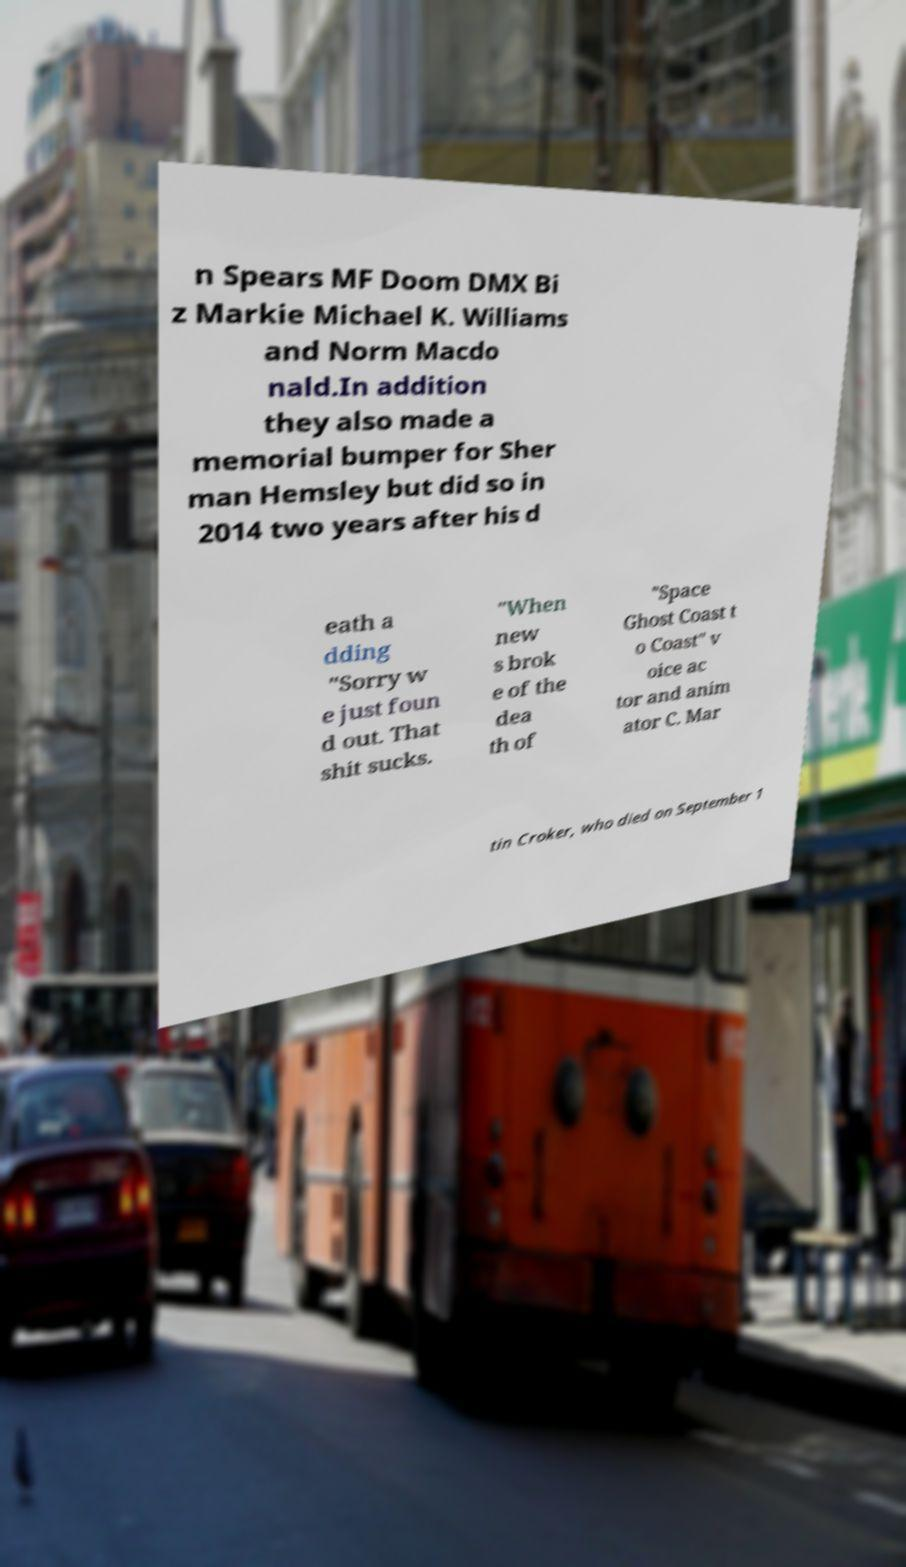Could you assist in decoding the text presented in this image and type it out clearly? n Spears MF Doom DMX Bi z Markie Michael K. Williams and Norm Macdo nald.In addition they also made a memorial bumper for Sher man Hemsley but did so in 2014 two years after his d eath a dding "Sorry w e just foun d out. That shit sucks. "When new s brok e of the dea th of "Space Ghost Coast t o Coast" v oice ac tor and anim ator C. Mar tin Croker, who died on September 1 